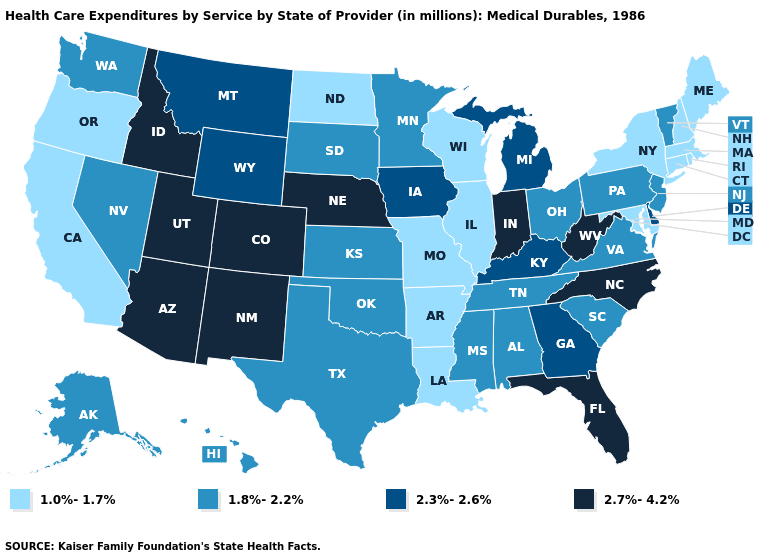What is the highest value in the South ?
Concise answer only. 2.7%-4.2%. Does Idaho have the highest value in the USA?
Concise answer only. Yes. What is the highest value in the South ?
Short answer required. 2.7%-4.2%. What is the highest value in the West ?
Give a very brief answer. 2.7%-4.2%. What is the value of Arizona?
Concise answer only. 2.7%-4.2%. What is the lowest value in the West?
Concise answer only. 1.0%-1.7%. Among the states that border Missouri , which have the highest value?
Quick response, please. Nebraska. What is the lowest value in the USA?
Keep it brief. 1.0%-1.7%. Is the legend a continuous bar?
Give a very brief answer. No. Which states have the lowest value in the USA?
Keep it brief. Arkansas, California, Connecticut, Illinois, Louisiana, Maine, Maryland, Massachusetts, Missouri, New Hampshire, New York, North Dakota, Oregon, Rhode Island, Wisconsin. What is the value of New Hampshire?
Answer briefly. 1.0%-1.7%. Name the states that have a value in the range 1.0%-1.7%?
Short answer required. Arkansas, California, Connecticut, Illinois, Louisiana, Maine, Maryland, Massachusetts, Missouri, New Hampshire, New York, North Dakota, Oregon, Rhode Island, Wisconsin. Name the states that have a value in the range 1.8%-2.2%?
Concise answer only. Alabama, Alaska, Hawaii, Kansas, Minnesota, Mississippi, Nevada, New Jersey, Ohio, Oklahoma, Pennsylvania, South Carolina, South Dakota, Tennessee, Texas, Vermont, Virginia, Washington. Name the states that have a value in the range 1.0%-1.7%?
Write a very short answer. Arkansas, California, Connecticut, Illinois, Louisiana, Maine, Maryland, Massachusetts, Missouri, New Hampshire, New York, North Dakota, Oregon, Rhode Island, Wisconsin. Does Delaware have the same value as South Carolina?
Answer briefly. No. 